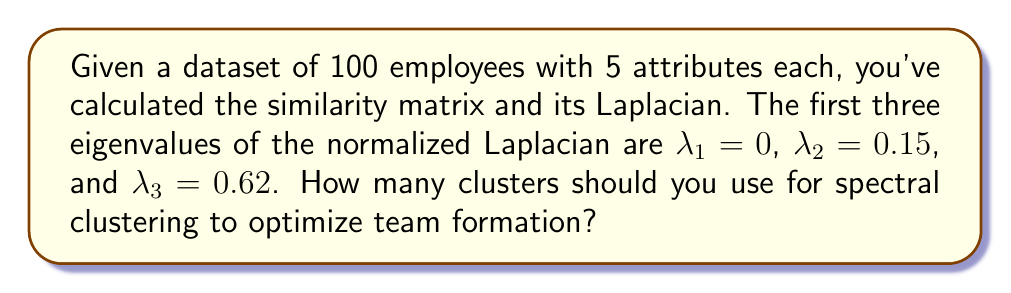Can you solve this math problem? To determine the optimal number of clusters for spectral clustering, we use the eigengap heuristic. This method involves analyzing the differences between consecutive eigenvalues of the normalized Laplacian matrix.

Step 1: Calculate the eigengaps
- Eigengap between $\lambda_1$ and $\lambda_2$: $0.15 - 0 = 0.15$
- Eigengap between $\lambda_2$ and $\lambda_3$: $0.62 - 0.15 = 0.47$

Step 2: Identify the largest eigengap
The largest eigengap is between $\lambda_2$ and $\lambda_3$, which is 0.47.

Step 3: Determine the number of clusters
The optimal number of clusters is equal to the index of the eigenvalue before the largest eigengap. In this case, it's the index of $\lambda_2$, which is 2.

Therefore, to optimize team formation based on the spectral clustering of employee data, you should use 2 clusters.
Answer: 2 clusters 